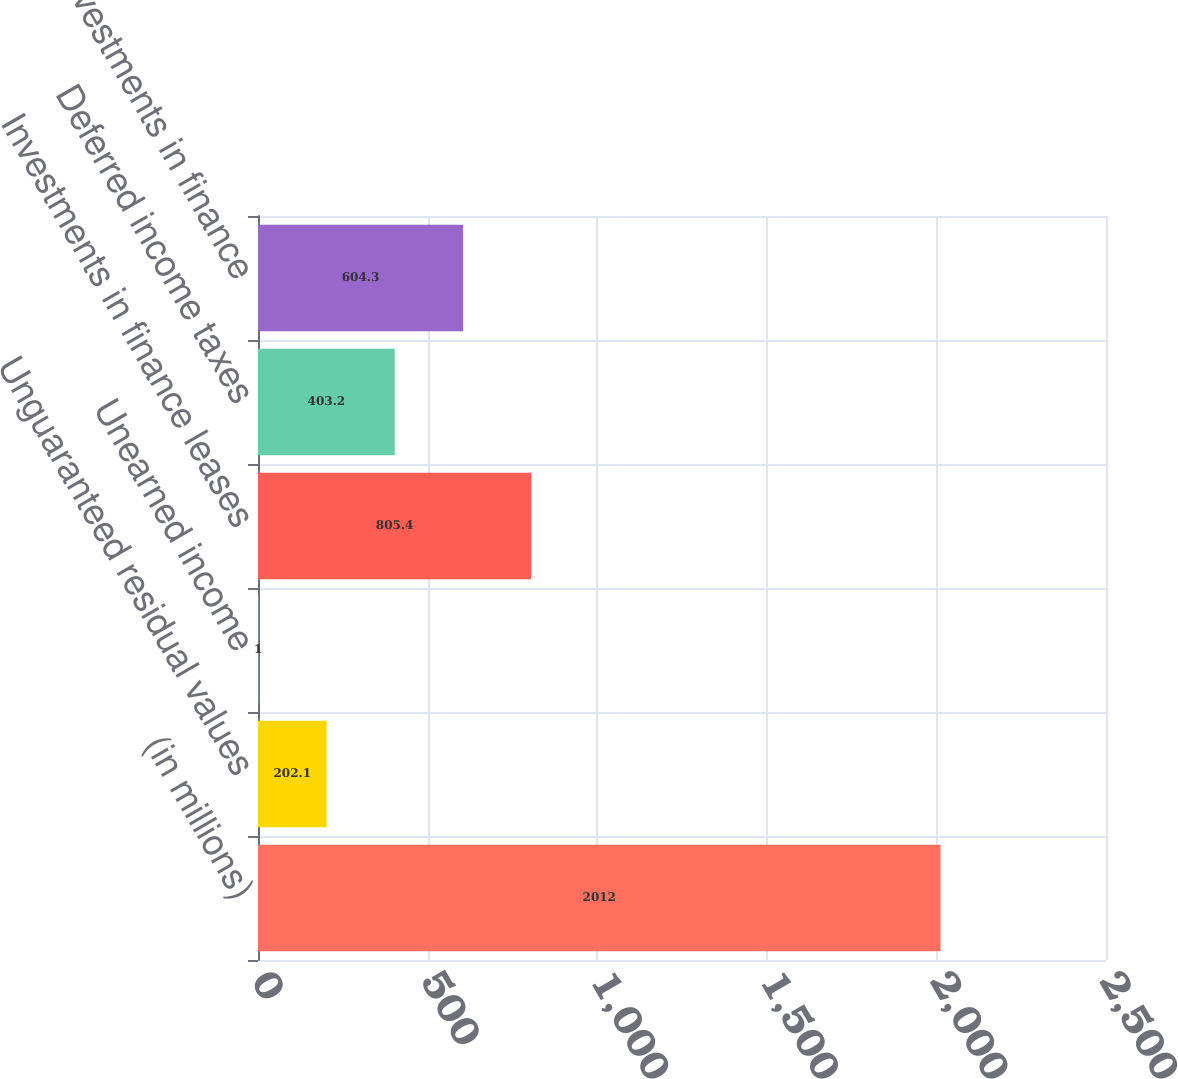<chart> <loc_0><loc_0><loc_500><loc_500><bar_chart><fcel>(in millions)<fcel>Unguaranteed residual values<fcel>Unearned income<fcel>Investments in finance leases<fcel>Deferred income taxes<fcel>Net investments in finance<nl><fcel>2012<fcel>202.1<fcel>1<fcel>805.4<fcel>403.2<fcel>604.3<nl></chart> 